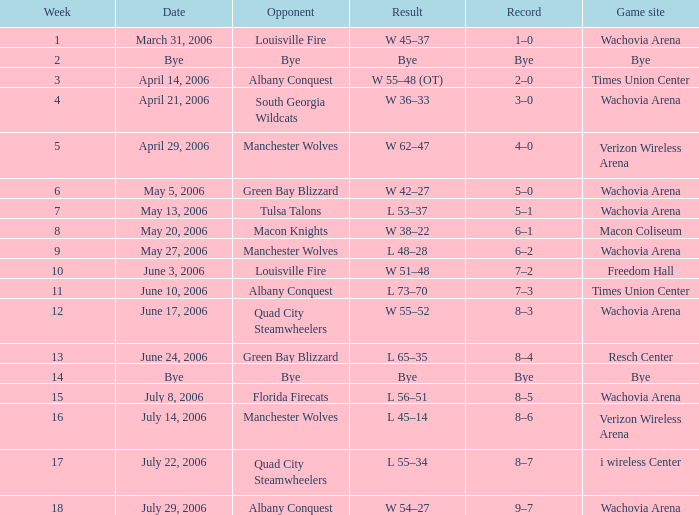What is the game platform week 1? Wachovia Arena. Could you parse the entire table as a dict? {'header': ['Week', 'Date', 'Opponent', 'Result', 'Record', 'Game site'], 'rows': [['1', 'March 31, 2006', 'Louisville Fire', 'W 45–37', '1–0', 'Wachovia Arena'], ['2', 'Bye', 'Bye', 'Bye', 'Bye', 'Bye'], ['3', 'April 14, 2006', 'Albany Conquest', 'W 55–48 (OT)', '2–0', 'Times Union Center'], ['4', 'April 21, 2006', 'South Georgia Wildcats', 'W 36–33', '3–0', 'Wachovia Arena'], ['5', 'April 29, 2006', 'Manchester Wolves', 'W 62–47', '4–0', 'Verizon Wireless Arena'], ['6', 'May 5, 2006', 'Green Bay Blizzard', 'W 42–27', '5–0', 'Wachovia Arena'], ['7', 'May 13, 2006', 'Tulsa Talons', 'L 53–37', '5–1', 'Wachovia Arena'], ['8', 'May 20, 2006', 'Macon Knights', 'W 38–22', '6–1', 'Macon Coliseum'], ['9', 'May 27, 2006', 'Manchester Wolves', 'L 48–28', '6–2', 'Wachovia Arena'], ['10', 'June 3, 2006', 'Louisville Fire', 'W 51–48', '7–2', 'Freedom Hall'], ['11', 'June 10, 2006', 'Albany Conquest', 'L 73–70', '7–3', 'Times Union Center'], ['12', 'June 17, 2006', 'Quad City Steamwheelers', 'W 55–52', '8–3', 'Wachovia Arena'], ['13', 'June 24, 2006', 'Green Bay Blizzard', 'L 65–35', '8–4', 'Resch Center'], ['14', 'Bye', 'Bye', 'Bye', 'Bye', 'Bye'], ['15', 'July 8, 2006', 'Florida Firecats', 'L 56–51', '8–5', 'Wachovia Arena'], ['16', 'July 14, 2006', 'Manchester Wolves', 'L 45–14', '8–6', 'Verizon Wireless Arena'], ['17', 'July 22, 2006', 'Quad City Steamwheelers', 'L 55–34', '8–7', 'i wireless Center'], ['18', 'July 29, 2006', 'Albany Conquest', 'W 54–27', '9–7', 'Wachovia Arena']]} 